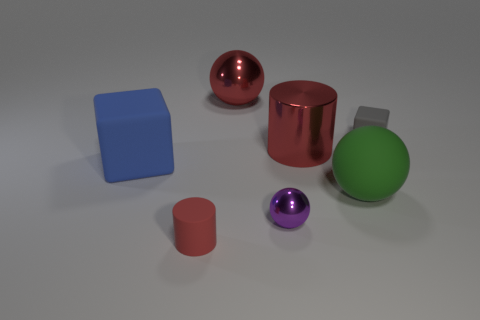Is there any other thing that is the same size as the blue block?
Ensure brevity in your answer.  Yes. What shape is the large green thing?
Ensure brevity in your answer.  Sphere. What is the shape of the rubber object that is on the left side of the tiny purple shiny ball and behind the tiny ball?
Give a very brief answer. Cube. There is a cylinder that is made of the same material as the small purple sphere; what color is it?
Keep it short and to the point. Red. The small rubber object that is right of the shiny object that is behind the matte cube that is right of the tiny red cylinder is what shape?
Offer a terse response. Cube. How big is the purple metal sphere?
Offer a very short reply. Small. There is a large object that is the same material as the big cylinder; what shape is it?
Offer a terse response. Sphere. Is the number of matte things on the left side of the small gray object less than the number of red metallic balls?
Provide a succinct answer. No. What is the color of the block left of the large red metal cylinder?
Make the answer very short. Blue. What is the material of the other cylinder that is the same color as the tiny cylinder?
Provide a short and direct response. Metal. 